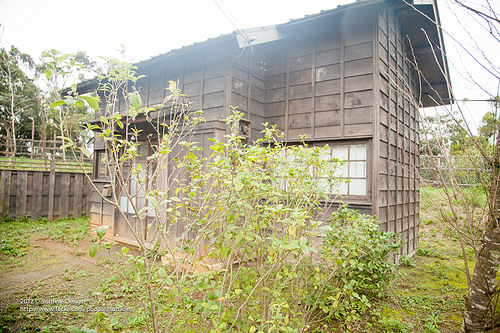<image>
Is there a building in front of the tree? No. The building is not in front of the tree. The spatial positioning shows a different relationship between these objects. 